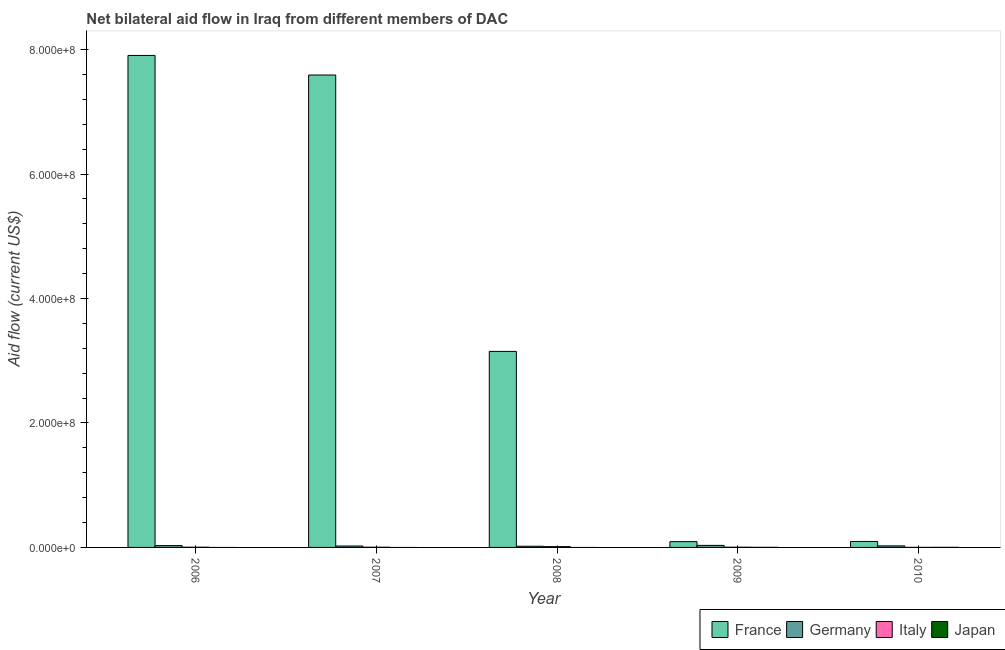How many different coloured bars are there?
Offer a very short reply. 4. How many bars are there on the 2nd tick from the left?
Your response must be concise. 3. How many bars are there on the 5th tick from the right?
Ensure brevity in your answer.  3. In how many cases, is the number of bars for a given year not equal to the number of legend labels?
Provide a succinct answer. 3. What is the amount of aid given by france in 2010?
Ensure brevity in your answer.  9.58e+06. Across all years, what is the maximum amount of aid given by japan?
Your response must be concise. 1.50e+05. What is the total amount of aid given by germany in the graph?
Offer a terse response. 1.29e+07. What is the difference between the amount of aid given by italy in 2009 and that in 2010?
Offer a very short reply. 2.80e+05. What is the difference between the amount of aid given by japan in 2010 and the amount of aid given by germany in 2007?
Offer a terse response. 1.50e+05. What is the average amount of aid given by italy per year?
Keep it short and to the point. 4.72e+05. What is the ratio of the amount of aid given by italy in 2006 to that in 2010?
Ensure brevity in your answer.  4.86. What is the difference between the highest and the lowest amount of aid given by japan?
Offer a terse response. 1.50e+05. In how many years, is the amount of aid given by japan greater than the average amount of aid given by japan taken over all years?
Make the answer very short. 2. Is it the case that in every year, the sum of the amount of aid given by france and amount of aid given by germany is greater than the amount of aid given by italy?
Give a very brief answer. Yes. Are all the bars in the graph horizontal?
Keep it short and to the point. No. How many years are there in the graph?
Ensure brevity in your answer.  5. Does the graph contain grids?
Your response must be concise. No. Where does the legend appear in the graph?
Your response must be concise. Bottom right. What is the title of the graph?
Keep it short and to the point. Net bilateral aid flow in Iraq from different members of DAC. Does "Debt policy" appear as one of the legend labels in the graph?
Your answer should be very brief. No. What is the label or title of the X-axis?
Offer a very short reply. Year. What is the label or title of the Y-axis?
Make the answer very short. Aid flow (current US$). What is the Aid flow (current US$) in France in 2006?
Ensure brevity in your answer.  7.91e+08. What is the Aid flow (current US$) in Germany in 2006?
Your answer should be compact. 2.93e+06. What is the Aid flow (current US$) in Italy in 2006?
Offer a very short reply. 3.40e+05. What is the Aid flow (current US$) in Japan in 2006?
Provide a short and direct response. 0. What is the Aid flow (current US$) in France in 2007?
Provide a succinct answer. 7.59e+08. What is the Aid flow (current US$) of Germany in 2007?
Offer a terse response. 2.27e+06. What is the Aid flow (current US$) of Italy in 2007?
Keep it short and to the point. 3.30e+05. What is the Aid flow (current US$) of Japan in 2007?
Make the answer very short. 0. What is the Aid flow (current US$) in France in 2008?
Offer a terse response. 3.15e+08. What is the Aid flow (current US$) of Germany in 2008?
Make the answer very short. 1.90e+06. What is the Aid flow (current US$) of Italy in 2008?
Give a very brief answer. 1.27e+06. What is the Aid flow (current US$) of Japan in 2008?
Ensure brevity in your answer.  0. What is the Aid flow (current US$) in France in 2009?
Make the answer very short. 9.29e+06. What is the Aid flow (current US$) of Germany in 2009?
Give a very brief answer. 3.29e+06. What is the Aid flow (current US$) in Japan in 2009?
Provide a succinct answer. 1.40e+05. What is the Aid flow (current US$) of France in 2010?
Offer a terse response. 9.58e+06. What is the Aid flow (current US$) in Germany in 2010?
Ensure brevity in your answer.  2.48e+06. What is the Aid flow (current US$) in Italy in 2010?
Your answer should be compact. 7.00e+04. What is the Aid flow (current US$) of Japan in 2010?
Keep it short and to the point. 1.50e+05. Across all years, what is the maximum Aid flow (current US$) in France?
Ensure brevity in your answer.  7.91e+08. Across all years, what is the maximum Aid flow (current US$) in Germany?
Make the answer very short. 3.29e+06. Across all years, what is the maximum Aid flow (current US$) of Italy?
Keep it short and to the point. 1.27e+06. Across all years, what is the minimum Aid flow (current US$) in France?
Your answer should be very brief. 9.29e+06. Across all years, what is the minimum Aid flow (current US$) in Germany?
Offer a terse response. 1.90e+06. What is the total Aid flow (current US$) in France in the graph?
Offer a terse response. 1.88e+09. What is the total Aid flow (current US$) in Germany in the graph?
Offer a very short reply. 1.29e+07. What is the total Aid flow (current US$) in Italy in the graph?
Provide a succinct answer. 2.36e+06. What is the total Aid flow (current US$) in Japan in the graph?
Your response must be concise. 2.90e+05. What is the difference between the Aid flow (current US$) of France in 2006 and that in 2007?
Keep it short and to the point. 3.15e+07. What is the difference between the Aid flow (current US$) of Germany in 2006 and that in 2007?
Provide a succinct answer. 6.60e+05. What is the difference between the Aid flow (current US$) of Italy in 2006 and that in 2007?
Give a very brief answer. 10000. What is the difference between the Aid flow (current US$) in France in 2006 and that in 2008?
Your answer should be compact. 4.76e+08. What is the difference between the Aid flow (current US$) in Germany in 2006 and that in 2008?
Make the answer very short. 1.03e+06. What is the difference between the Aid flow (current US$) of Italy in 2006 and that in 2008?
Offer a very short reply. -9.30e+05. What is the difference between the Aid flow (current US$) of France in 2006 and that in 2009?
Provide a short and direct response. 7.81e+08. What is the difference between the Aid flow (current US$) of Germany in 2006 and that in 2009?
Ensure brevity in your answer.  -3.60e+05. What is the difference between the Aid flow (current US$) in Italy in 2006 and that in 2009?
Your answer should be compact. -10000. What is the difference between the Aid flow (current US$) of France in 2006 and that in 2010?
Make the answer very short. 7.81e+08. What is the difference between the Aid flow (current US$) in Germany in 2006 and that in 2010?
Your response must be concise. 4.50e+05. What is the difference between the Aid flow (current US$) in France in 2007 and that in 2008?
Ensure brevity in your answer.  4.44e+08. What is the difference between the Aid flow (current US$) in Germany in 2007 and that in 2008?
Offer a terse response. 3.70e+05. What is the difference between the Aid flow (current US$) of Italy in 2007 and that in 2008?
Ensure brevity in your answer.  -9.40e+05. What is the difference between the Aid flow (current US$) in France in 2007 and that in 2009?
Provide a short and direct response. 7.50e+08. What is the difference between the Aid flow (current US$) of Germany in 2007 and that in 2009?
Give a very brief answer. -1.02e+06. What is the difference between the Aid flow (current US$) in France in 2007 and that in 2010?
Your answer should be compact. 7.50e+08. What is the difference between the Aid flow (current US$) of Germany in 2007 and that in 2010?
Keep it short and to the point. -2.10e+05. What is the difference between the Aid flow (current US$) of Italy in 2007 and that in 2010?
Keep it short and to the point. 2.60e+05. What is the difference between the Aid flow (current US$) in France in 2008 and that in 2009?
Ensure brevity in your answer.  3.06e+08. What is the difference between the Aid flow (current US$) in Germany in 2008 and that in 2009?
Provide a short and direct response. -1.39e+06. What is the difference between the Aid flow (current US$) in Italy in 2008 and that in 2009?
Your response must be concise. 9.20e+05. What is the difference between the Aid flow (current US$) of France in 2008 and that in 2010?
Give a very brief answer. 3.05e+08. What is the difference between the Aid flow (current US$) in Germany in 2008 and that in 2010?
Your response must be concise. -5.80e+05. What is the difference between the Aid flow (current US$) of Italy in 2008 and that in 2010?
Offer a very short reply. 1.20e+06. What is the difference between the Aid flow (current US$) in France in 2009 and that in 2010?
Offer a very short reply. -2.90e+05. What is the difference between the Aid flow (current US$) in Germany in 2009 and that in 2010?
Provide a short and direct response. 8.10e+05. What is the difference between the Aid flow (current US$) of Italy in 2009 and that in 2010?
Provide a succinct answer. 2.80e+05. What is the difference between the Aid flow (current US$) in Japan in 2009 and that in 2010?
Offer a terse response. -10000. What is the difference between the Aid flow (current US$) of France in 2006 and the Aid flow (current US$) of Germany in 2007?
Your answer should be compact. 7.88e+08. What is the difference between the Aid flow (current US$) in France in 2006 and the Aid flow (current US$) in Italy in 2007?
Ensure brevity in your answer.  7.90e+08. What is the difference between the Aid flow (current US$) of Germany in 2006 and the Aid flow (current US$) of Italy in 2007?
Your answer should be very brief. 2.60e+06. What is the difference between the Aid flow (current US$) in France in 2006 and the Aid flow (current US$) in Germany in 2008?
Your answer should be very brief. 7.89e+08. What is the difference between the Aid flow (current US$) in France in 2006 and the Aid flow (current US$) in Italy in 2008?
Your answer should be compact. 7.89e+08. What is the difference between the Aid flow (current US$) of Germany in 2006 and the Aid flow (current US$) of Italy in 2008?
Ensure brevity in your answer.  1.66e+06. What is the difference between the Aid flow (current US$) of France in 2006 and the Aid flow (current US$) of Germany in 2009?
Give a very brief answer. 7.87e+08. What is the difference between the Aid flow (current US$) in France in 2006 and the Aid flow (current US$) in Italy in 2009?
Provide a short and direct response. 7.90e+08. What is the difference between the Aid flow (current US$) in France in 2006 and the Aid flow (current US$) in Japan in 2009?
Your answer should be very brief. 7.91e+08. What is the difference between the Aid flow (current US$) of Germany in 2006 and the Aid flow (current US$) of Italy in 2009?
Your answer should be compact. 2.58e+06. What is the difference between the Aid flow (current US$) in Germany in 2006 and the Aid flow (current US$) in Japan in 2009?
Offer a terse response. 2.79e+06. What is the difference between the Aid flow (current US$) of France in 2006 and the Aid flow (current US$) of Germany in 2010?
Provide a short and direct response. 7.88e+08. What is the difference between the Aid flow (current US$) in France in 2006 and the Aid flow (current US$) in Italy in 2010?
Offer a very short reply. 7.91e+08. What is the difference between the Aid flow (current US$) in France in 2006 and the Aid flow (current US$) in Japan in 2010?
Your response must be concise. 7.91e+08. What is the difference between the Aid flow (current US$) in Germany in 2006 and the Aid flow (current US$) in Italy in 2010?
Give a very brief answer. 2.86e+06. What is the difference between the Aid flow (current US$) of Germany in 2006 and the Aid flow (current US$) of Japan in 2010?
Offer a very short reply. 2.78e+06. What is the difference between the Aid flow (current US$) of Italy in 2006 and the Aid flow (current US$) of Japan in 2010?
Make the answer very short. 1.90e+05. What is the difference between the Aid flow (current US$) of France in 2007 and the Aid flow (current US$) of Germany in 2008?
Your answer should be very brief. 7.57e+08. What is the difference between the Aid flow (current US$) of France in 2007 and the Aid flow (current US$) of Italy in 2008?
Offer a terse response. 7.58e+08. What is the difference between the Aid flow (current US$) in France in 2007 and the Aid flow (current US$) in Germany in 2009?
Your answer should be very brief. 7.56e+08. What is the difference between the Aid flow (current US$) in France in 2007 and the Aid flow (current US$) in Italy in 2009?
Your answer should be compact. 7.59e+08. What is the difference between the Aid flow (current US$) of France in 2007 and the Aid flow (current US$) of Japan in 2009?
Make the answer very short. 7.59e+08. What is the difference between the Aid flow (current US$) of Germany in 2007 and the Aid flow (current US$) of Italy in 2009?
Make the answer very short. 1.92e+06. What is the difference between the Aid flow (current US$) of Germany in 2007 and the Aid flow (current US$) of Japan in 2009?
Your response must be concise. 2.13e+06. What is the difference between the Aid flow (current US$) in France in 2007 and the Aid flow (current US$) in Germany in 2010?
Ensure brevity in your answer.  7.57e+08. What is the difference between the Aid flow (current US$) of France in 2007 and the Aid flow (current US$) of Italy in 2010?
Your answer should be compact. 7.59e+08. What is the difference between the Aid flow (current US$) of France in 2007 and the Aid flow (current US$) of Japan in 2010?
Make the answer very short. 7.59e+08. What is the difference between the Aid flow (current US$) in Germany in 2007 and the Aid flow (current US$) in Italy in 2010?
Your answer should be compact. 2.20e+06. What is the difference between the Aid flow (current US$) in Germany in 2007 and the Aid flow (current US$) in Japan in 2010?
Your answer should be very brief. 2.12e+06. What is the difference between the Aid flow (current US$) of France in 2008 and the Aid flow (current US$) of Germany in 2009?
Give a very brief answer. 3.12e+08. What is the difference between the Aid flow (current US$) in France in 2008 and the Aid flow (current US$) in Italy in 2009?
Your answer should be very brief. 3.15e+08. What is the difference between the Aid flow (current US$) of France in 2008 and the Aid flow (current US$) of Japan in 2009?
Offer a very short reply. 3.15e+08. What is the difference between the Aid flow (current US$) in Germany in 2008 and the Aid flow (current US$) in Italy in 2009?
Offer a very short reply. 1.55e+06. What is the difference between the Aid flow (current US$) in Germany in 2008 and the Aid flow (current US$) in Japan in 2009?
Give a very brief answer. 1.76e+06. What is the difference between the Aid flow (current US$) in Italy in 2008 and the Aid flow (current US$) in Japan in 2009?
Provide a succinct answer. 1.13e+06. What is the difference between the Aid flow (current US$) in France in 2008 and the Aid flow (current US$) in Germany in 2010?
Give a very brief answer. 3.13e+08. What is the difference between the Aid flow (current US$) of France in 2008 and the Aid flow (current US$) of Italy in 2010?
Make the answer very short. 3.15e+08. What is the difference between the Aid flow (current US$) of France in 2008 and the Aid flow (current US$) of Japan in 2010?
Ensure brevity in your answer.  3.15e+08. What is the difference between the Aid flow (current US$) in Germany in 2008 and the Aid flow (current US$) in Italy in 2010?
Offer a terse response. 1.83e+06. What is the difference between the Aid flow (current US$) of Germany in 2008 and the Aid flow (current US$) of Japan in 2010?
Provide a succinct answer. 1.75e+06. What is the difference between the Aid flow (current US$) of Italy in 2008 and the Aid flow (current US$) of Japan in 2010?
Your answer should be compact. 1.12e+06. What is the difference between the Aid flow (current US$) of France in 2009 and the Aid flow (current US$) of Germany in 2010?
Give a very brief answer. 6.81e+06. What is the difference between the Aid flow (current US$) of France in 2009 and the Aid flow (current US$) of Italy in 2010?
Your answer should be very brief. 9.22e+06. What is the difference between the Aid flow (current US$) in France in 2009 and the Aid flow (current US$) in Japan in 2010?
Ensure brevity in your answer.  9.14e+06. What is the difference between the Aid flow (current US$) in Germany in 2009 and the Aid flow (current US$) in Italy in 2010?
Your answer should be compact. 3.22e+06. What is the difference between the Aid flow (current US$) of Germany in 2009 and the Aid flow (current US$) of Japan in 2010?
Make the answer very short. 3.14e+06. What is the average Aid flow (current US$) of France per year?
Offer a very short reply. 3.77e+08. What is the average Aid flow (current US$) of Germany per year?
Give a very brief answer. 2.57e+06. What is the average Aid flow (current US$) of Italy per year?
Provide a succinct answer. 4.72e+05. What is the average Aid flow (current US$) in Japan per year?
Your answer should be compact. 5.80e+04. In the year 2006, what is the difference between the Aid flow (current US$) in France and Aid flow (current US$) in Germany?
Ensure brevity in your answer.  7.88e+08. In the year 2006, what is the difference between the Aid flow (current US$) in France and Aid flow (current US$) in Italy?
Your answer should be very brief. 7.90e+08. In the year 2006, what is the difference between the Aid flow (current US$) in Germany and Aid flow (current US$) in Italy?
Your answer should be compact. 2.59e+06. In the year 2007, what is the difference between the Aid flow (current US$) in France and Aid flow (current US$) in Germany?
Keep it short and to the point. 7.57e+08. In the year 2007, what is the difference between the Aid flow (current US$) of France and Aid flow (current US$) of Italy?
Ensure brevity in your answer.  7.59e+08. In the year 2007, what is the difference between the Aid flow (current US$) in Germany and Aid flow (current US$) in Italy?
Offer a terse response. 1.94e+06. In the year 2008, what is the difference between the Aid flow (current US$) in France and Aid flow (current US$) in Germany?
Provide a succinct answer. 3.13e+08. In the year 2008, what is the difference between the Aid flow (current US$) of France and Aid flow (current US$) of Italy?
Offer a terse response. 3.14e+08. In the year 2008, what is the difference between the Aid flow (current US$) of Germany and Aid flow (current US$) of Italy?
Keep it short and to the point. 6.30e+05. In the year 2009, what is the difference between the Aid flow (current US$) in France and Aid flow (current US$) in Italy?
Ensure brevity in your answer.  8.94e+06. In the year 2009, what is the difference between the Aid flow (current US$) in France and Aid flow (current US$) in Japan?
Your response must be concise. 9.15e+06. In the year 2009, what is the difference between the Aid flow (current US$) of Germany and Aid flow (current US$) of Italy?
Make the answer very short. 2.94e+06. In the year 2009, what is the difference between the Aid flow (current US$) in Germany and Aid flow (current US$) in Japan?
Your answer should be very brief. 3.15e+06. In the year 2010, what is the difference between the Aid flow (current US$) in France and Aid flow (current US$) in Germany?
Provide a succinct answer. 7.10e+06. In the year 2010, what is the difference between the Aid flow (current US$) of France and Aid flow (current US$) of Italy?
Make the answer very short. 9.51e+06. In the year 2010, what is the difference between the Aid flow (current US$) in France and Aid flow (current US$) in Japan?
Keep it short and to the point. 9.43e+06. In the year 2010, what is the difference between the Aid flow (current US$) of Germany and Aid flow (current US$) of Italy?
Offer a terse response. 2.41e+06. In the year 2010, what is the difference between the Aid flow (current US$) of Germany and Aid flow (current US$) of Japan?
Keep it short and to the point. 2.33e+06. What is the ratio of the Aid flow (current US$) in France in 2006 to that in 2007?
Your response must be concise. 1.04. What is the ratio of the Aid flow (current US$) in Germany in 2006 to that in 2007?
Your answer should be very brief. 1.29. What is the ratio of the Aid flow (current US$) in Italy in 2006 to that in 2007?
Offer a terse response. 1.03. What is the ratio of the Aid flow (current US$) of France in 2006 to that in 2008?
Make the answer very short. 2.51. What is the ratio of the Aid flow (current US$) in Germany in 2006 to that in 2008?
Your response must be concise. 1.54. What is the ratio of the Aid flow (current US$) in Italy in 2006 to that in 2008?
Your response must be concise. 0.27. What is the ratio of the Aid flow (current US$) of France in 2006 to that in 2009?
Ensure brevity in your answer.  85.11. What is the ratio of the Aid flow (current US$) in Germany in 2006 to that in 2009?
Your response must be concise. 0.89. What is the ratio of the Aid flow (current US$) in Italy in 2006 to that in 2009?
Offer a very short reply. 0.97. What is the ratio of the Aid flow (current US$) of France in 2006 to that in 2010?
Your answer should be compact. 82.54. What is the ratio of the Aid flow (current US$) in Germany in 2006 to that in 2010?
Provide a succinct answer. 1.18. What is the ratio of the Aid flow (current US$) in Italy in 2006 to that in 2010?
Ensure brevity in your answer.  4.86. What is the ratio of the Aid flow (current US$) of France in 2007 to that in 2008?
Offer a terse response. 2.41. What is the ratio of the Aid flow (current US$) of Germany in 2007 to that in 2008?
Keep it short and to the point. 1.19. What is the ratio of the Aid flow (current US$) in Italy in 2007 to that in 2008?
Provide a succinct answer. 0.26. What is the ratio of the Aid flow (current US$) of France in 2007 to that in 2009?
Make the answer very short. 81.73. What is the ratio of the Aid flow (current US$) in Germany in 2007 to that in 2009?
Your answer should be very brief. 0.69. What is the ratio of the Aid flow (current US$) in Italy in 2007 to that in 2009?
Provide a short and direct response. 0.94. What is the ratio of the Aid flow (current US$) of France in 2007 to that in 2010?
Your response must be concise. 79.25. What is the ratio of the Aid flow (current US$) in Germany in 2007 to that in 2010?
Offer a terse response. 0.92. What is the ratio of the Aid flow (current US$) in Italy in 2007 to that in 2010?
Your response must be concise. 4.71. What is the ratio of the Aid flow (current US$) in France in 2008 to that in 2009?
Your response must be concise. 33.91. What is the ratio of the Aid flow (current US$) of Germany in 2008 to that in 2009?
Your answer should be very brief. 0.58. What is the ratio of the Aid flow (current US$) in Italy in 2008 to that in 2009?
Keep it short and to the point. 3.63. What is the ratio of the Aid flow (current US$) of France in 2008 to that in 2010?
Your response must be concise. 32.89. What is the ratio of the Aid flow (current US$) of Germany in 2008 to that in 2010?
Ensure brevity in your answer.  0.77. What is the ratio of the Aid flow (current US$) of Italy in 2008 to that in 2010?
Ensure brevity in your answer.  18.14. What is the ratio of the Aid flow (current US$) of France in 2009 to that in 2010?
Make the answer very short. 0.97. What is the ratio of the Aid flow (current US$) in Germany in 2009 to that in 2010?
Your response must be concise. 1.33. What is the ratio of the Aid flow (current US$) in Italy in 2009 to that in 2010?
Provide a short and direct response. 5. What is the ratio of the Aid flow (current US$) of Japan in 2009 to that in 2010?
Provide a short and direct response. 0.93. What is the difference between the highest and the second highest Aid flow (current US$) in France?
Offer a terse response. 3.15e+07. What is the difference between the highest and the second highest Aid flow (current US$) in Italy?
Give a very brief answer. 9.20e+05. What is the difference between the highest and the lowest Aid flow (current US$) of France?
Ensure brevity in your answer.  7.81e+08. What is the difference between the highest and the lowest Aid flow (current US$) in Germany?
Provide a short and direct response. 1.39e+06. What is the difference between the highest and the lowest Aid flow (current US$) of Italy?
Give a very brief answer. 1.20e+06. What is the difference between the highest and the lowest Aid flow (current US$) in Japan?
Provide a short and direct response. 1.50e+05. 